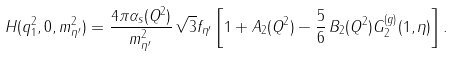Convert formula to latex. <formula><loc_0><loc_0><loc_500><loc_500>H ( q _ { 1 } ^ { 2 } , 0 , m _ { \eta ^ { \prime } } ^ { 2 } ) = \frac { 4 \pi \alpha _ { s } ( Q ^ { 2 } ) } { m _ { \eta ^ { \prime } } ^ { 2 } } \, \sqrt { 3 } f _ { \eta ^ { \prime } } \left [ 1 + A _ { 2 } ( Q ^ { 2 } ) - \frac { 5 } { 6 } \, B _ { 2 } ( Q ^ { 2 } ) G _ { 2 } ^ { ( g ) } ( 1 , \eta ) \right ] .</formula> 